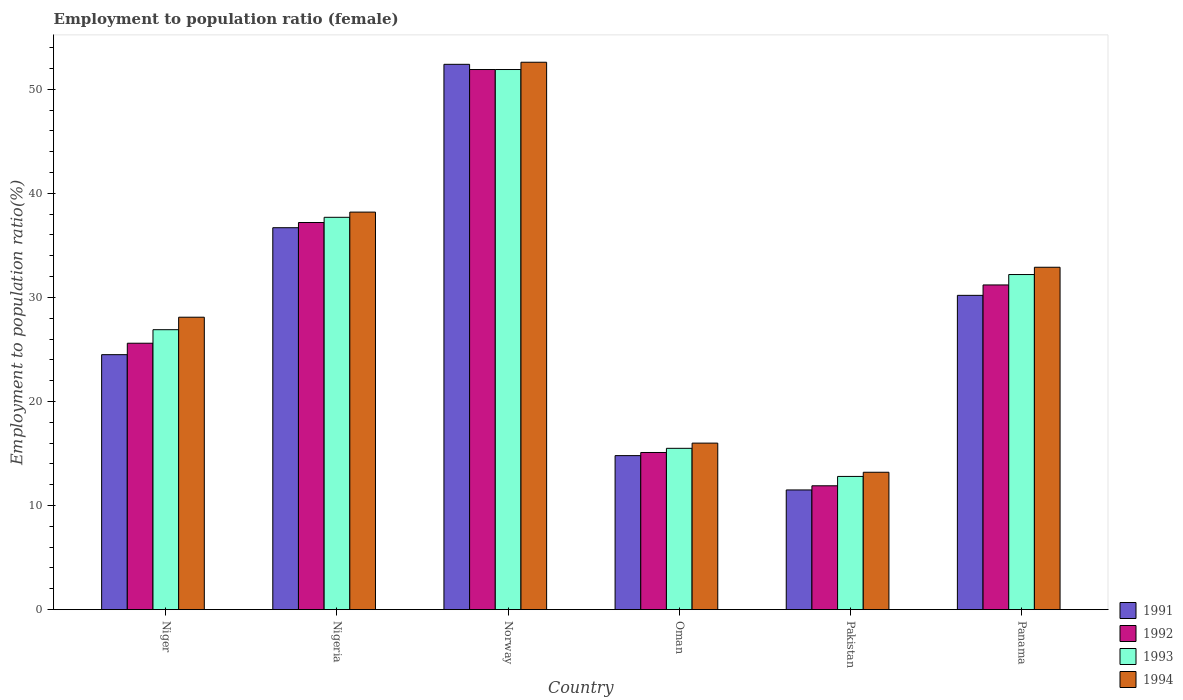How many different coloured bars are there?
Give a very brief answer. 4. Are the number of bars per tick equal to the number of legend labels?
Your answer should be compact. Yes. Are the number of bars on each tick of the X-axis equal?
Your answer should be compact. Yes. How many bars are there on the 4th tick from the left?
Your answer should be very brief. 4. What is the label of the 1st group of bars from the left?
Provide a succinct answer. Niger. What is the employment to population ratio in 1991 in Nigeria?
Give a very brief answer. 36.7. Across all countries, what is the maximum employment to population ratio in 1991?
Provide a succinct answer. 52.4. Across all countries, what is the minimum employment to population ratio in 1991?
Make the answer very short. 11.5. In which country was the employment to population ratio in 1993 minimum?
Make the answer very short. Pakistan. What is the total employment to population ratio in 1994 in the graph?
Offer a very short reply. 181. What is the difference between the employment to population ratio in 1991 in Nigeria and that in Norway?
Give a very brief answer. -15.7. What is the difference between the employment to population ratio in 1993 in Norway and the employment to population ratio in 1991 in Niger?
Keep it short and to the point. 27.4. What is the average employment to population ratio in 1992 per country?
Ensure brevity in your answer.  28.82. What is the difference between the employment to population ratio of/in 1992 and employment to population ratio of/in 1993 in Pakistan?
Provide a succinct answer. -0.9. In how many countries, is the employment to population ratio in 1991 greater than 38 %?
Provide a short and direct response. 1. What is the ratio of the employment to population ratio in 1991 in Norway to that in Pakistan?
Your answer should be very brief. 4.56. Is the employment to population ratio in 1994 in Niger less than that in Panama?
Give a very brief answer. Yes. Is the difference between the employment to population ratio in 1992 in Norway and Oman greater than the difference between the employment to population ratio in 1993 in Norway and Oman?
Your answer should be very brief. Yes. What is the difference between the highest and the second highest employment to population ratio in 1991?
Your answer should be compact. 15.7. What is the difference between the highest and the lowest employment to population ratio in 1992?
Your answer should be compact. 40. Is the sum of the employment to population ratio in 1992 in Nigeria and Panama greater than the maximum employment to population ratio in 1993 across all countries?
Keep it short and to the point. Yes. Is it the case that in every country, the sum of the employment to population ratio in 1992 and employment to population ratio in 1994 is greater than the sum of employment to population ratio in 1991 and employment to population ratio in 1993?
Keep it short and to the point. No. What does the 2nd bar from the right in Norway represents?
Give a very brief answer. 1993. Is it the case that in every country, the sum of the employment to population ratio in 1993 and employment to population ratio in 1994 is greater than the employment to population ratio in 1991?
Your response must be concise. Yes. What is the difference between two consecutive major ticks on the Y-axis?
Ensure brevity in your answer.  10. Does the graph contain grids?
Your answer should be compact. No. How are the legend labels stacked?
Offer a terse response. Vertical. What is the title of the graph?
Your answer should be compact. Employment to population ratio (female). What is the label or title of the Y-axis?
Offer a very short reply. Employment to population ratio(%). What is the Employment to population ratio(%) in 1992 in Niger?
Make the answer very short. 25.6. What is the Employment to population ratio(%) of 1993 in Niger?
Your answer should be compact. 26.9. What is the Employment to population ratio(%) of 1994 in Niger?
Your response must be concise. 28.1. What is the Employment to population ratio(%) of 1991 in Nigeria?
Offer a very short reply. 36.7. What is the Employment to population ratio(%) of 1992 in Nigeria?
Give a very brief answer. 37.2. What is the Employment to population ratio(%) in 1993 in Nigeria?
Your answer should be compact. 37.7. What is the Employment to population ratio(%) of 1994 in Nigeria?
Offer a terse response. 38.2. What is the Employment to population ratio(%) of 1991 in Norway?
Offer a terse response. 52.4. What is the Employment to population ratio(%) of 1992 in Norway?
Offer a very short reply. 51.9. What is the Employment to population ratio(%) of 1993 in Norway?
Provide a short and direct response. 51.9. What is the Employment to population ratio(%) of 1994 in Norway?
Your answer should be very brief. 52.6. What is the Employment to population ratio(%) of 1991 in Oman?
Ensure brevity in your answer.  14.8. What is the Employment to population ratio(%) of 1992 in Oman?
Your answer should be compact. 15.1. What is the Employment to population ratio(%) of 1991 in Pakistan?
Give a very brief answer. 11.5. What is the Employment to population ratio(%) of 1992 in Pakistan?
Your response must be concise. 11.9. What is the Employment to population ratio(%) in 1993 in Pakistan?
Your response must be concise. 12.8. What is the Employment to population ratio(%) of 1994 in Pakistan?
Give a very brief answer. 13.2. What is the Employment to population ratio(%) in 1991 in Panama?
Offer a very short reply. 30.2. What is the Employment to population ratio(%) of 1992 in Panama?
Your answer should be very brief. 31.2. What is the Employment to population ratio(%) of 1993 in Panama?
Your response must be concise. 32.2. What is the Employment to population ratio(%) in 1994 in Panama?
Offer a terse response. 32.9. Across all countries, what is the maximum Employment to population ratio(%) in 1991?
Offer a very short reply. 52.4. Across all countries, what is the maximum Employment to population ratio(%) of 1992?
Your answer should be very brief. 51.9. Across all countries, what is the maximum Employment to population ratio(%) of 1993?
Your answer should be very brief. 51.9. Across all countries, what is the maximum Employment to population ratio(%) in 1994?
Offer a terse response. 52.6. Across all countries, what is the minimum Employment to population ratio(%) in 1991?
Make the answer very short. 11.5. Across all countries, what is the minimum Employment to population ratio(%) of 1992?
Ensure brevity in your answer.  11.9. Across all countries, what is the minimum Employment to population ratio(%) of 1993?
Your answer should be compact. 12.8. Across all countries, what is the minimum Employment to population ratio(%) in 1994?
Provide a succinct answer. 13.2. What is the total Employment to population ratio(%) of 1991 in the graph?
Ensure brevity in your answer.  170.1. What is the total Employment to population ratio(%) of 1992 in the graph?
Your answer should be very brief. 172.9. What is the total Employment to population ratio(%) of 1993 in the graph?
Provide a succinct answer. 177. What is the total Employment to population ratio(%) of 1994 in the graph?
Provide a succinct answer. 181. What is the difference between the Employment to population ratio(%) in 1993 in Niger and that in Nigeria?
Offer a terse response. -10.8. What is the difference between the Employment to population ratio(%) of 1994 in Niger and that in Nigeria?
Provide a short and direct response. -10.1. What is the difference between the Employment to population ratio(%) in 1991 in Niger and that in Norway?
Keep it short and to the point. -27.9. What is the difference between the Employment to population ratio(%) of 1992 in Niger and that in Norway?
Your answer should be very brief. -26.3. What is the difference between the Employment to population ratio(%) of 1994 in Niger and that in Norway?
Give a very brief answer. -24.5. What is the difference between the Employment to population ratio(%) in 1992 in Niger and that in Oman?
Your answer should be very brief. 10.5. What is the difference between the Employment to population ratio(%) in 1991 in Niger and that in Pakistan?
Your response must be concise. 13. What is the difference between the Employment to population ratio(%) in 1992 in Niger and that in Pakistan?
Your answer should be very brief. 13.7. What is the difference between the Employment to population ratio(%) in 1994 in Niger and that in Pakistan?
Offer a very short reply. 14.9. What is the difference between the Employment to population ratio(%) of 1991 in Niger and that in Panama?
Make the answer very short. -5.7. What is the difference between the Employment to population ratio(%) of 1992 in Niger and that in Panama?
Keep it short and to the point. -5.6. What is the difference between the Employment to population ratio(%) of 1993 in Niger and that in Panama?
Provide a succinct answer. -5.3. What is the difference between the Employment to population ratio(%) of 1991 in Nigeria and that in Norway?
Offer a terse response. -15.7. What is the difference between the Employment to population ratio(%) in 1992 in Nigeria and that in Norway?
Offer a terse response. -14.7. What is the difference between the Employment to population ratio(%) in 1994 in Nigeria and that in Norway?
Offer a terse response. -14.4. What is the difference between the Employment to population ratio(%) in 1991 in Nigeria and that in Oman?
Your answer should be compact. 21.9. What is the difference between the Employment to population ratio(%) of 1992 in Nigeria and that in Oman?
Make the answer very short. 22.1. What is the difference between the Employment to population ratio(%) in 1993 in Nigeria and that in Oman?
Offer a very short reply. 22.2. What is the difference between the Employment to population ratio(%) in 1991 in Nigeria and that in Pakistan?
Offer a terse response. 25.2. What is the difference between the Employment to population ratio(%) of 1992 in Nigeria and that in Pakistan?
Provide a short and direct response. 25.3. What is the difference between the Employment to population ratio(%) in 1993 in Nigeria and that in Pakistan?
Your answer should be very brief. 24.9. What is the difference between the Employment to population ratio(%) in 1992 in Nigeria and that in Panama?
Keep it short and to the point. 6. What is the difference between the Employment to population ratio(%) of 1993 in Nigeria and that in Panama?
Provide a short and direct response. 5.5. What is the difference between the Employment to population ratio(%) in 1991 in Norway and that in Oman?
Make the answer very short. 37.6. What is the difference between the Employment to population ratio(%) of 1992 in Norway and that in Oman?
Your answer should be very brief. 36.8. What is the difference between the Employment to population ratio(%) in 1993 in Norway and that in Oman?
Your response must be concise. 36.4. What is the difference between the Employment to population ratio(%) in 1994 in Norway and that in Oman?
Make the answer very short. 36.6. What is the difference between the Employment to population ratio(%) in 1991 in Norway and that in Pakistan?
Your answer should be very brief. 40.9. What is the difference between the Employment to population ratio(%) in 1992 in Norway and that in Pakistan?
Keep it short and to the point. 40. What is the difference between the Employment to population ratio(%) of 1993 in Norway and that in Pakistan?
Offer a very short reply. 39.1. What is the difference between the Employment to population ratio(%) in 1994 in Norway and that in Pakistan?
Offer a terse response. 39.4. What is the difference between the Employment to population ratio(%) in 1992 in Norway and that in Panama?
Your response must be concise. 20.7. What is the difference between the Employment to population ratio(%) of 1993 in Norway and that in Panama?
Provide a succinct answer. 19.7. What is the difference between the Employment to population ratio(%) in 1994 in Norway and that in Panama?
Provide a short and direct response. 19.7. What is the difference between the Employment to population ratio(%) in 1991 in Oman and that in Pakistan?
Provide a succinct answer. 3.3. What is the difference between the Employment to population ratio(%) in 1992 in Oman and that in Pakistan?
Give a very brief answer. 3.2. What is the difference between the Employment to population ratio(%) in 1991 in Oman and that in Panama?
Give a very brief answer. -15.4. What is the difference between the Employment to population ratio(%) in 1992 in Oman and that in Panama?
Provide a succinct answer. -16.1. What is the difference between the Employment to population ratio(%) of 1993 in Oman and that in Panama?
Your answer should be compact. -16.7. What is the difference between the Employment to population ratio(%) in 1994 in Oman and that in Panama?
Give a very brief answer. -16.9. What is the difference between the Employment to population ratio(%) in 1991 in Pakistan and that in Panama?
Your answer should be very brief. -18.7. What is the difference between the Employment to population ratio(%) of 1992 in Pakistan and that in Panama?
Your answer should be compact. -19.3. What is the difference between the Employment to population ratio(%) in 1993 in Pakistan and that in Panama?
Offer a terse response. -19.4. What is the difference between the Employment to population ratio(%) of 1994 in Pakistan and that in Panama?
Keep it short and to the point. -19.7. What is the difference between the Employment to population ratio(%) of 1991 in Niger and the Employment to population ratio(%) of 1992 in Nigeria?
Your response must be concise. -12.7. What is the difference between the Employment to population ratio(%) of 1991 in Niger and the Employment to population ratio(%) of 1994 in Nigeria?
Make the answer very short. -13.7. What is the difference between the Employment to population ratio(%) of 1992 in Niger and the Employment to population ratio(%) of 1993 in Nigeria?
Keep it short and to the point. -12.1. What is the difference between the Employment to population ratio(%) of 1992 in Niger and the Employment to population ratio(%) of 1994 in Nigeria?
Offer a terse response. -12.6. What is the difference between the Employment to population ratio(%) of 1993 in Niger and the Employment to population ratio(%) of 1994 in Nigeria?
Your answer should be compact. -11.3. What is the difference between the Employment to population ratio(%) in 1991 in Niger and the Employment to population ratio(%) in 1992 in Norway?
Provide a short and direct response. -27.4. What is the difference between the Employment to population ratio(%) in 1991 in Niger and the Employment to population ratio(%) in 1993 in Norway?
Your answer should be compact. -27.4. What is the difference between the Employment to population ratio(%) of 1991 in Niger and the Employment to population ratio(%) of 1994 in Norway?
Make the answer very short. -28.1. What is the difference between the Employment to population ratio(%) of 1992 in Niger and the Employment to population ratio(%) of 1993 in Norway?
Give a very brief answer. -26.3. What is the difference between the Employment to population ratio(%) of 1993 in Niger and the Employment to population ratio(%) of 1994 in Norway?
Your response must be concise. -25.7. What is the difference between the Employment to population ratio(%) in 1991 in Niger and the Employment to population ratio(%) in 1992 in Oman?
Offer a very short reply. 9.4. What is the difference between the Employment to population ratio(%) of 1991 in Niger and the Employment to population ratio(%) of 1994 in Oman?
Give a very brief answer. 8.5. What is the difference between the Employment to population ratio(%) of 1992 in Niger and the Employment to population ratio(%) of 1993 in Oman?
Ensure brevity in your answer.  10.1. What is the difference between the Employment to population ratio(%) of 1992 in Niger and the Employment to population ratio(%) of 1994 in Oman?
Your answer should be very brief. 9.6. What is the difference between the Employment to population ratio(%) in 1991 in Niger and the Employment to population ratio(%) in 1992 in Pakistan?
Your response must be concise. 12.6. What is the difference between the Employment to population ratio(%) in 1991 in Niger and the Employment to population ratio(%) in 1994 in Pakistan?
Give a very brief answer. 11.3. What is the difference between the Employment to population ratio(%) in 1992 in Niger and the Employment to population ratio(%) in 1994 in Pakistan?
Give a very brief answer. 12.4. What is the difference between the Employment to population ratio(%) in 1991 in Niger and the Employment to population ratio(%) in 1992 in Panama?
Your answer should be very brief. -6.7. What is the difference between the Employment to population ratio(%) of 1992 in Niger and the Employment to population ratio(%) of 1993 in Panama?
Provide a succinct answer. -6.6. What is the difference between the Employment to population ratio(%) in 1992 in Niger and the Employment to population ratio(%) in 1994 in Panama?
Your answer should be compact. -7.3. What is the difference between the Employment to population ratio(%) of 1993 in Niger and the Employment to population ratio(%) of 1994 in Panama?
Ensure brevity in your answer.  -6. What is the difference between the Employment to population ratio(%) of 1991 in Nigeria and the Employment to population ratio(%) of 1992 in Norway?
Offer a terse response. -15.2. What is the difference between the Employment to population ratio(%) in 1991 in Nigeria and the Employment to population ratio(%) in 1993 in Norway?
Keep it short and to the point. -15.2. What is the difference between the Employment to population ratio(%) in 1991 in Nigeria and the Employment to population ratio(%) in 1994 in Norway?
Provide a short and direct response. -15.9. What is the difference between the Employment to population ratio(%) of 1992 in Nigeria and the Employment to population ratio(%) of 1993 in Norway?
Your answer should be compact. -14.7. What is the difference between the Employment to population ratio(%) of 1992 in Nigeria and the Employment to population ratio(%) of 1994 in Norway?
Provide a short and direct response. -15.4. What is the difference between the Employment to population ratio(%) in 1993 in Nigeria and the Employment to population ratio(%) in 1994 in Norway?
Provide a succinct answer. -14.9. What is the difference between the Employment to population ratio(%) in 1991 in Nigeria and the Employment to population ratio(%) in 1992 in Oman?
Provide a succinct answer. 21.6. What is the difference between the Employment to population ratio(%) of 1991 in Nigeria and the Employment to population ratio(%) of 1993 in Oman?
Your answer should be compact. 21.2. What is the difference between the Employment to population ratio(%) in 1991 in Nigeria and the Employment to population ratio(%) in 1994 in Oman?
Offer a very short reply. 20.7. What is the difference between the Employment to population ratio(%) in 1992 in Nigeria and the Employment to population ratio(%) in 1993 in Oman?
Offer a very short reply. 21.7. What is the difference between the Employment to population ratio(%) of 1992 in Nigeria and the Employment to population ratio(%) of 1994 in Oman?
Provide a succinct answer. 21.2. What is the difference between the Employment to population ratio(%) of 1993 in Nigeria and the Employment to population ratio(%) of 1994 in Oman?
Make the answer very short. 21.7. What is the difference between the Employment to population ratio(%) in 1991 in Nigeria and the Employment to population ratio(%) in 1992 in Pakistan?
Provide a succinct answer. 24.8. What is the difference between the Employment to population ratio(%) of 1991 in Nigeria and the Employment to population ratio(%) of 1993 in Pakistan?
Ensure brevity in your answer.  23.9. What is the difference between the Employment to population ratio(%) of 1992 in Nigeria and the Employment to population ratio(%) of 1993 in Pakistan?
Provide a succinct answer. 24.4. What is the difference between the Employment to population ratio(%) of 1993 in Nigeria and the Employment to population ratio(%) of 1994 in Pakistan?
Your answer should be compact. 24.5. What is the difference between the Employment to population ratio(%) of 1991 in Nigeria and the Employment to population ratio(%) of 1992 in Panama?
Provide a succinct answer. 5.5. What is the difference between the Employment to population ratio(%) in 1993 in Nigeria and the Employment to population ratio(%) in 1994 in Panama?
Make the answer very short. 4.8. What is the difference between the Employment to population ratio(%) in 1991 in Norway and the Employment to population ratio(%) in 1992 in Oman?
Your answer should be compact. 37.3. What is the difference between the Employment to population ratio(%) in 1991 in Norway and the Employment to population ratio(%) in 1993 in Oman?
Your response must be concise. 36.9. What is the difference between the Employment to population ratio(%) of 1991 in Norway and the Employment to population ratio(%) of 1994 in Oman?
Provide a succinct answer. 36.4. What is the difference between the Employment to population ratio(%) of 1992 in Norway and the Employment to population ratio(%) of 1993 in Oman?
Offer a very short reply. 36.4. What is the difference between the Employment to population ratio(%) of 1992 in Norway and the Employment to population ratio(%) of 1994 in Oman?
Your response must be concise. 35.9. What is the difference between the Employment to population ratio(%) of 1993 in Norway and the Employment to population ratio(%) of 1994 in Oman?
Your answer should be compact. 35.9. What is the difference between the Employment to population ratio(%) of 1991 in Norway and the Employment to population ratio(%) of 1992 in Pakistan?
Give a very brief answer. 40.5. What is the difference between the Employment to population ratio(%) of 1991 in Norway and the Employment to population ratio(%) of 1993 in Pakistan?
Provide a succinct answer. 39.6. What is the difference between the Employment to population ratio(%) in 1991 in Norway and the Employment to population ratio(%) in 1994 in Pakistan?
Offer a terse response. 39.2. What is the difference between the Employment to population ratio(%) in 1992 in Norway and the Employment to population ratio(%) in 1993 in Pakistan?
Ensure brevity in your answer.  39.1. What is the difference between the Employment to population ratio(%) in 1992 in Norway and the Employment to population ratio(%) in 1994 in Pakistan?
Provide a succinct answer. 38.7. What is the difference between the Employment to population ratio(%) in 1993 in Norway and the Employment to population ratio(%) in 1994 in Pakistan?
Your answer should be compact. 38.7. What is the difference between the Employment to population ratio(%) in 1991 in Norway and the Employment to population ratio(%) in 1992 in Panama?
Offer a very short reply. 21.2. What is the difference between the Employment to population ratio(%) in 1991 in Norway and the Employment to population ratio(%) in 1993 in Panama?
Provide a succinct answer. 20.2. What is the difference between the Employment to population ratio(%) of 1993 in Norway and the Employment to population ratio(%) of 1994 in Panama?
Ensure brevity in your answer.  19. What is the difference between the Employment to population ratio(%) in 1992 in Oman and the Employment to population ratio(%) in 1993 in Pakistan?
Your answer should be compact. 2.3. What is the difference between the Employment to population ratio(%) of 1993 in Oman and the Employment to population ratio(%) of 1994 in Pakistan?
Keep it short and to the point. 2.3. What is the difference between the Employment to population ratio(%) in 1991 in Oman and the Employment to population ratio(%) in 1992 in Panama?
Provide a succinct answer. -16.4. What is the difference between the Employment to population ratio(%) of 1991 in Oman and the Employment to population ratio(%) of 1993 in Panama?
Offer a very short reply. -17.4. What is the difference between the Employment to population ratio(%) of 1991 in Oman and the Employment to population ratio(%) of 1994 in Panama?
Make the answer very short. -18.1. What is the difference between the Employment to population ratio(%) of 1992 in Oman and the Employment to population ratio(%) of 1993 in Panama?
Give a very brief answer. -17.1. What is the difference between the Employment to population ratio(%) in 1992 in Oman and the Employment to population ratio(%) in 1994 in Panama?
Make the answer very short. -17.8. What is the difference between the Employment to population ratio(%) in 1993 in Oman and the Employment to population ratio(%) in 1994 in Panama?
Your answer should be compact. -17.4. What is the difference between the Employment to population ratio(%) of 1991 in Pakistan and the Employment to population ratio(%) of 1992 in Panama?
Keep it short and to the point. -19.7. What is the difference between the Employment to population ratio(%) in 1991 in Pakistan and the Employment to population ratio(%) in 1993 in Panama?
Your response must be concise. -20.7. What is the difference between the Employment to population ratio(%) in 1991 in Pakistan and the Employment to population ratio(%) in 1994 in Panama?
Your response must be concise. -21.4. What is the difference between the Employment to population ratio(%) in 1992 in Pakistan and the Employment to population ratio(%) in 1993 in Panama?
Keep it short and to the point. -20.3. What is the difference between the Employment to population ratio(%) of 1993 in Pakistan and the Employment to population ratio(%) of 1994 in Panama?
Ensure brevity in your answer.  -20.1. What is the average Employment to population ratio(%) in 1991 per country?
Provide a short and direct response. 28.35. What is the average Employment to population ratio(%) in 1992 per country?
Provide a succinct answer. 28.82. What is the average Employment to population ratio(%) of 1993 per country?
Provide a short and direct response. 29.5. What is the average Employment to population ratio(%) of 1994 per country?
Make the answer very short. 30.17. What is the difference between the Employment to population ratio(%) of 1991 and Employment to population ratio(%) of 1992 in Niger?
Ensure brevity in your answer.  -1.1. What is the difference between the Employment to population ratio(%) of 1991 and Employment to population ratio(%) of 1994 in Niger?
Give a very brief answer. -3.6. What is the difference between the Employment to population ratio(%) in 1992 and Employment to population ratio(%) in 1993 in Niger?
Provide a short and direct response. -1.3. What is the difference between the Employment to population ratio(%) in 1992 and Employment to population ratio(%) in 1994 in Niger?
Offer a very short reply. -2.5. What is the difference between the Employment to population ratio(%) in 1991 and Employment to population ratio(%) in 1993 in Nigeria?
Your answer should be very brief. -1. What is the difference between the Employment to population ratio(%) of 1991 and Employment to population ratio(%) of 1994 in Nigeria?
Ensure brevity in your answer.  -1.5. What is the difference between the Employment to population ratio(%) of 1992 and Employment to population ratio(%) of 1993 in Nigeria?
Offer a very short reply. -0.5. What is the difference between the Employment to population ratio(%) of 1992 and Employment to population ratio(%) of 1994 in Nigeria?
Make the answer very short. -1. What is the difference between the Employment to population ratio(%) in 1992 and Employment to population ratio(%) in 1993 in Norway?
Give a very brief answer. 0. What is the difference between the Employment to population ratio(%) of 1992 and Employment to population ratio(%) of 1994 in Norway?
Provide a succinct answer. -0.7. What is the difference between the Employment to population ratio(%) in 1993 and Employment to population ratio(%) in 1994 in Norway?
Your answer should be very brief. -0.7. What is the difference between the Employment to population ratio(%) of 1991 and Employment to population ratio(%) of 1993 in Oman?
Ensure brevity in your answer.  -0.7. What is the difference between the Employment to population ratio(%) of 1991 and Employment to population ratio(%) of 1994 in Oman?
Offer a terse response. -1.2. What is the difference between the Employment to population ratio(%) in 1992 and Employment to population ratio(%) in 1993 in Oman?
Your answer should be very brief. -0.4. What is the difference between the Employment to population ratio(%) in 1991 and Employment to population ratio(%) in 1992 in Pakistan?
Provide a short and direct response. -0.4. What is the difference between the Employment to population ratio(%) of 1991 and Employment to population ratio(%) of 1993 in Pakistan?
Make the answer very short. -1.3. What is the difference between the Employment to population ratio(%) in 1991 and Employment to population ratio(%) in 1994 in Pakistan?
Ensure brevity in your answer.  -1.7. What is the difference between the Employment to population ratio(%) in 1992 and Employment to population ratio(%) in 1993 in Pakistan?
Keep it short and to the point. -0.9. What is the difference between the Employment to population ratio(%) of 1991 and Employment to population ratio(%) of 1994 in Panama?
Provide a succinct answer. -2.7. What is the difference between the Employment to population ratio(%) of 1992 and Employment to population ratio(%) of 1993 in Panama?
Give a very brief answer. -1. What is the ratio of the Employment to population ratio(%) in 1991 in Niger to that in Nigeria?
Make the answer very short. 0.67. What is the ratio of the Employment to population ratio(%) in 1992 in Niger to that in Nigeria?
Provide a succinct answer. 0.69. What is the ratio of the Employment to population ratio(%) in 1993 in Niger to that in Nigeria?
Provide a short and direct response. 0.71. What is the ratio of the Employment to population ratio(%) of 1994 in Niger to that in Nigeria?
Give a very brief answer. 0.74. What is the ratio of the Employment to population ratio(%) of 1991 in Niger to that in Norway?
Ensure brevity in your answer.  0.47. What is the ratio of the Employment to population ratio(%) in 1992 in Niger to that in Norway?
Your answer should be very brief. 0.49. What is the ratio of the Employment to population ratio(%) in 1993 in Niger to that in Norway?
Provide a succinct answer. 0.52. What is the ratio of the Employment to population ratio(%) of 1994 in Niger to that in Norway?
Provide a succinct answer. 0.53. What is the ratio of the Employment to population ratio(%) in 1991 in Niger to that in Oman?
Offer a very short reply. 1.66. What is the ratio of the Employment to population ratio(%) of 1992 in Niger to that in Oman?
Offer a terse response. 1.7. What is the ratio of the Employment to population ratio(%) in 1993 in Niger to that in Oman?
Provide a succinct answer. 1.74. What is the ratio of the Employment to population ratio(%) in 1994 in Niger to that in Oman?
Offer a terse response. 1.76. What is the ratio of the Employment to population ratio(%) of 1991 in Niger to that in Pakistan?
Your answer should be very brief. 2.13. What is the ratio of the Employment to population ratio(%) in 1992 in Niger to that in Pakistan?
Ensure brevity in your answer.  2.15. What is the ratio of the Employment to population ratio(%) of 1993 in Niger to that in Pakistan?
Your response must be concise. 2.1. What is the ratio of the Employment to population ratio(%) in 1994 in Niger to that in Pakistan?
Keep it short and to the point. 2.13. What is the ratio of the Employment to population ratio(%) in 1991 in Niger to that in Panama?
Keep it short and to the point. 0.81. What is the ratio of the Employment to population ratio(%) in 1992 in Niger to that in Panama?
Offer a very short reply. 0.82. What is the ratio of the Employment to population ratio(%) of 1993 in Niger to that in Panama?
Provide a short and direct response. 0.84. What is the ratio of the Employment to population ratio(%) of 1994 in Niger to that in Panama?
Provide a short and direct response. 0.85. What is the ratio of the Employment to population ratio(%) in 1991 in Nigeria to that in Norway?
Offer a terse response. 0.7. What is the ratio of the Employment to population ratio(%) of 1992 in Nigeria to that in Norway?
Offer a terse response. 0.72. What is the ratio of the Employment to population ratio(%) in 1993 in Nigeria to that in Norway?
Ensure brevity in your answer.  0.73. What is the ratio of the Employment to population ratio(%) in 1994 in Nigeria to that in Norway?
Ensure brevity in your answer.  0.73. What is the ratio of the Employment to population ratio(%) in 1991 in Nigeria to that in Oman?
Offer a terse response. 2.48. What is the ratio of the Employment to population ratio(%) of 1992 in Nigeria to that in Oman?
Offer a very short reply. 2.46. What is the ratio of the Employment to population ratio(%) in 1993 in Nigeria to that in Oman?
Your answer should be very brief. 2.43. What is the ratio of the Employment to population ratio(%) of 1994 in Nigeria to that in Oman?
Provide a short and direct response. 2.39. What is the ratio of the Employment to population ratio(%) of 1991 in Nigeria to that in Pakistan?
Offer a very short reply. 3.19. What is the ratio of the Employment to population ratio(%) of 1992 in Nigeria to that in Pakistan?
Provide a succinct answer. 3.13. What is the ratio of the Employment to population ratio(%) in 1993 in Nigeria to that in Pakistan?
Ensure brevity in your answer.  2.95. What is the ratio of the Employment to population ratio(%) in 1994 in Nigeria to that in Pakistan?
Keep it short and to the point. 2.89. What is the ratio of the Employment to population ratio(%) in 1991 in Nigeria to that in Panama?
Your answer should be very brief. 1.22. What is the ratio of the Employment to population ratio(%) of 1992 in Nigeria to that in Panama?
Your answer should be very brief. 1.19. What is the ratio of the Employment to population ratio(%) of 1993 in Nigeria to that in Panama?
Offer a very short reply. 1.17. What is the ratio of the Employment to population ratio(%) of 1994 in Nigeria to that in Panama?
Offer a very short reply. 1.16. What is the ratio of the Employment to population ratio(%) in 1991 in Norway to that in Oman?
Ensure brevity in your answer.  3.54. What is the ratio of the Employment to population ratio(%) of 1992 in Norway to that in Oman?
Keep it short and to the point. 3.44. What is the ratio of the Employment to population ratio(%) of 1993 in Norway to that in Oman?
Provide a succinct answer. 3.35. What is the ratio of the Employment to population ratio(%) of 1994 in Norway to that in Oman?
Keep it short and to the point. 3.29. What is the ratio of the Employment to population ratio(%) of 1991 in Norway to that in Pakistan?
Offer a terse response. 4.56. What is the ratio of the Employment to population ratio(%) in 1992 in Norway to that in Pakistan?
Provide a short and direct response. 4.36. What is the ratio of the Employment to population ratio(%) of 1993 in Norway to that in Pakistan?
Your answer should be compact. 4.05. What is the ratio of the Employment to population ratio(%) of 1994 in Norway to that in Pakistan?
Your response must be concise. 3.98. What is the ratio of the Employment to population ratio(%) of 1991 in Norway to that in Panama?
Provide a succinct answer. 1.74. What is the ratio of the Employment to population ratio(%) of 1992 in Norway to that in Panama?
Give a very brief answer. 1.66. What is the ratio of the Employment to population ratio(%) in 1993 in Norway to that in Panama?
Keep it short and to the point. 1.61. What is the ratio of the Employment to population ratio(%) in 1994 in Norway to that in Panama?
Your response must be concise. 1.6. What is the ratio of the Employment to population ratio(%) in 1991 in Oman to that in Pakistan?
Provide a short and direct response. 1.29. What is the ratio of the Employment to population ratio(%) of 1992 in Oman to that in Pakistan?
Your response must be concise. 1.27. What is the ratio of the Employment to population ratio(%) of 1993 in Oman to that in Pakistan?
Your answer should be compact. 1.21. What is the ratio of the Employment to population ratio(%) in 1994 in Oman to that in Pakistan?
Provide a short and direct response. 1.21. What is the ratio of the Employment to population ratio(%) of 1991 in Oman to that in Panama?
Offer a terse response. 0.49. What is the ratio of the Employment to population ratio(%) in 1992 in Oman to that in Panama?
Your response must be concise. 0.48. What is the ratio of the Employment to population ratio(%) in 1993 in Oman to that in Panama?
Offer a terse response. 0.48. What is the ratio of the Employment to population ratio(%) of 1994 in Oman to that in Panama?
Make the answer very short. 0.49. What is the ratio of the Employment to population ratio(%) of 1991 in Pakistan to that in Panama?
Offer a terse response. 0.38. What is the ratio of the Employment to population ratio(%) in 1992 in Pakistan to that in Panama?
Offer a terse response. 0.38. What is the ratio of the Employment to population ratio(%) of 1993 in Pakistan to that in Panama?
Give a very brief answer. 0.4. What is the ratio of the Employment to population ratio(%) of 1994 in Pakistan to that in Panama?
Make the answer very short. 0.4. What is the difference between the highest and the second highest Employment to population ratio(%) of 1991?
Your answer should be compact. 15.7. What is the difference between the highest and the lowest Employment to population ratio(%) of 1991?
Your response must be concise. 40.9. What is the difference between the highest and the lowest Employment to population ratio(%) of 1992?
Keep it short and to the point. 40. What is the difference between the highest and the lowest Employment to population ratio(%) of 1993?
Make the answer very short. 39.1. What is the difference between the highest and the lowest Employment to population ratio(%) in 1994?
Ensure brevity in your answer.  39.4. 